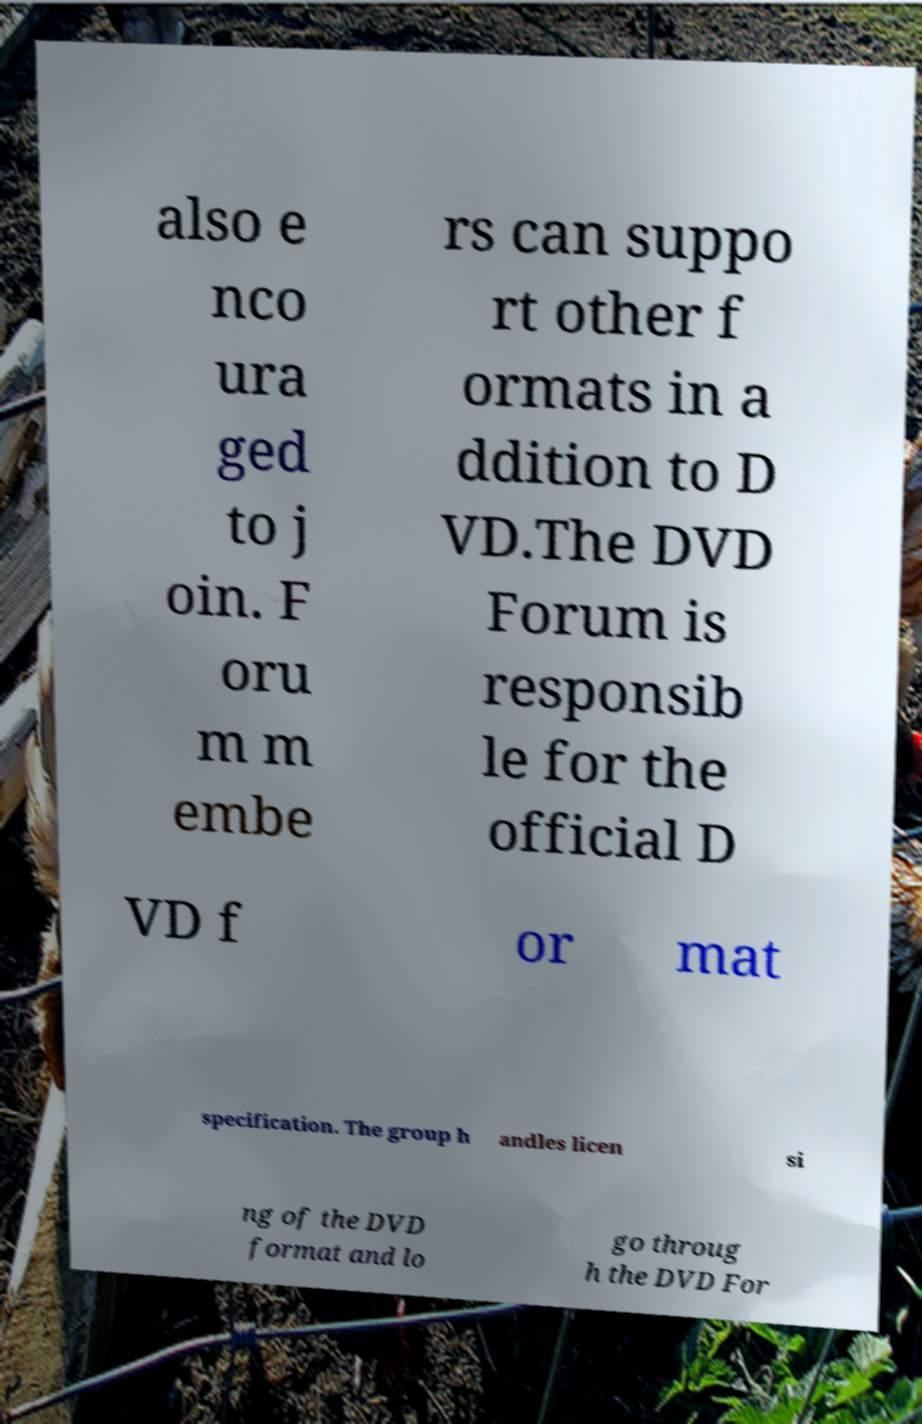Could you extract and type out the text from this image? also e nco ura ged to j oin. F oru m m embe rs can suppo rt other f ormats in a ddition to D VD.The DVD Forum is responsib le for the official D VD f or mat specification. The group h andles licen si ng of the DVD format and lo go throug h the DVD For 